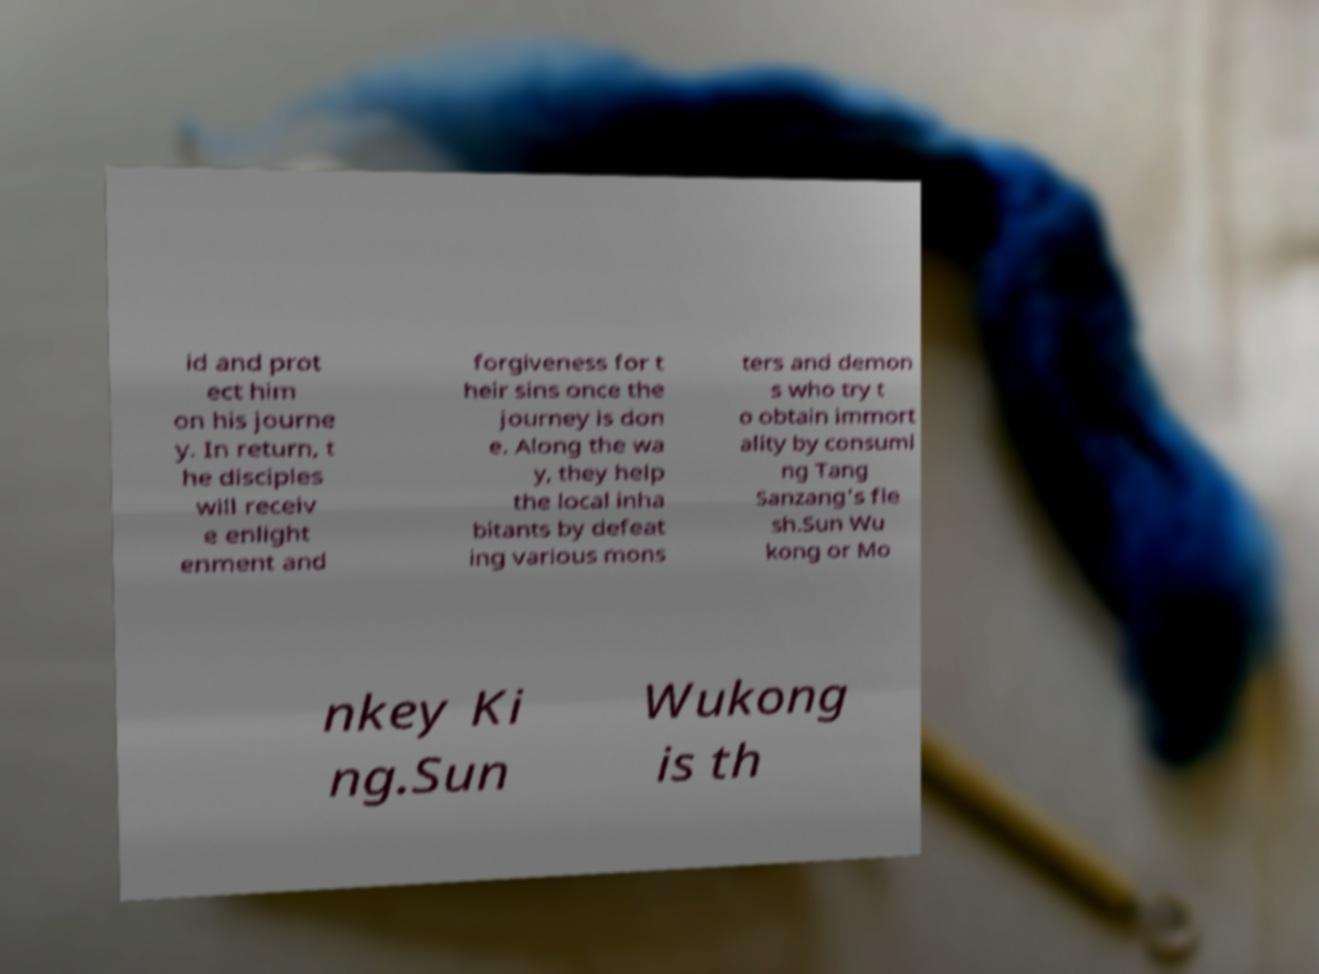I need the written content from this picture converted into text. Can you do that? id and prot ect him on his journe y. In return, t he disciples will receiv e enlight enment and forgiveness for t heir sins once the journey is don e. Along the wa y, they help the local inha bitants by defeat ing various mons ters and demon s who try t o obtain immort ality by consumi ng Tang Sanzang's fle sh.Sun Wu kong or Mo nkey Ki ng.Sun Wukong is th 